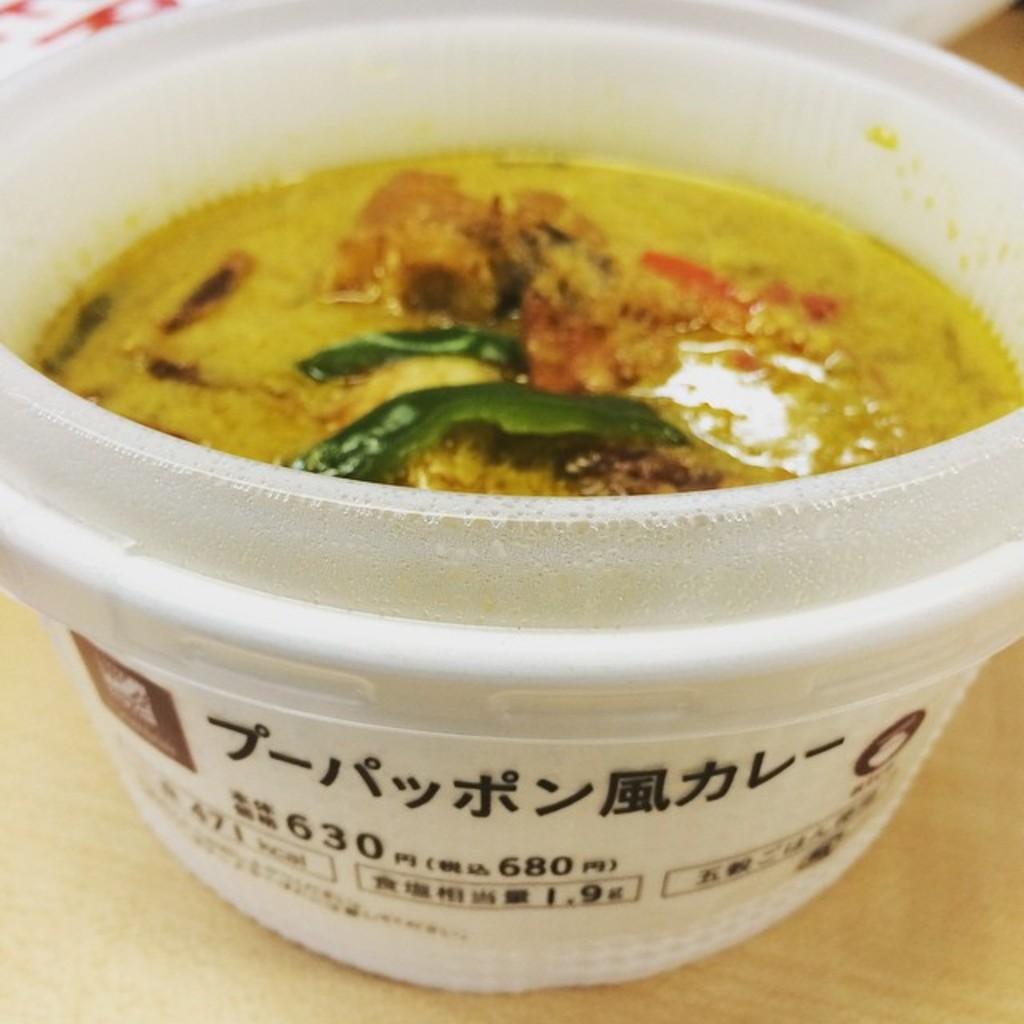Can you describe this image briefly? In this image I can see the cream colored surface and on it I can see a white colored bowl in which I can see a food item which is green, yellow, red and brown in color. 